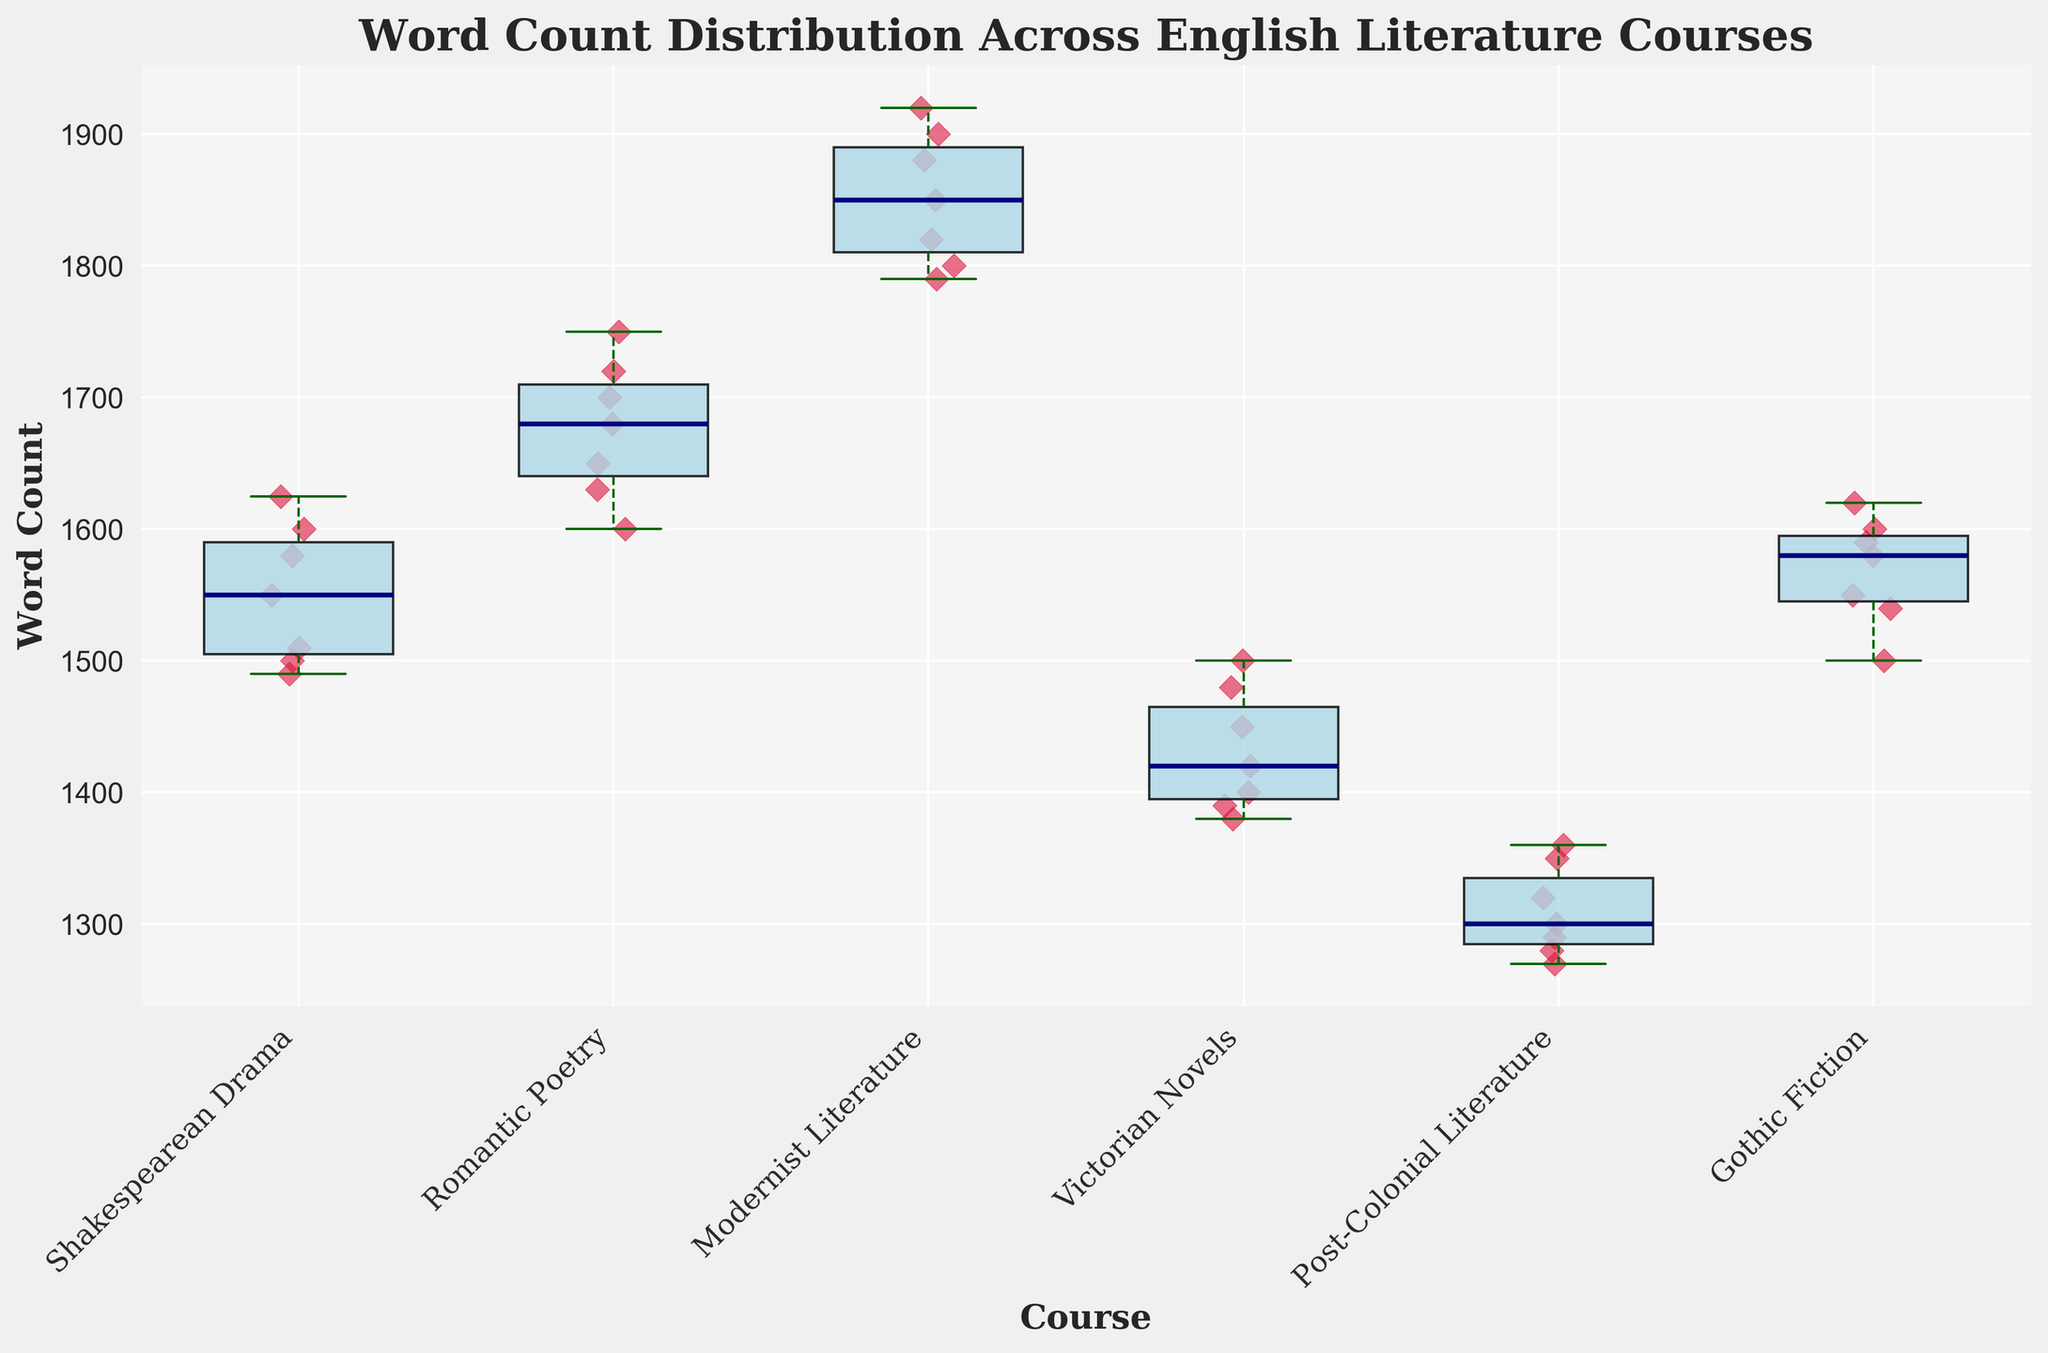What's the title of the figure? The title of the figure is the text located at the top of the plot, typically in a larger and bold font. It is explicitly defined and easy to identify.
Answer: Word Count Distribution Across English Literature Courses Which course has the highest median word count? The median word count of each course is represented by the bold line in the middle of each box. The highest median line appears to belong to the "Modernist Literature" course.
Answer: Modernist Literature Which course shows the greatest variation in word count? The variation in word count is indicated by the spread or length of the box and whiskers. The course with the widest box and longest whiskers represents the greatest variation. By examining these features, "Modernist Literature" appears to have the greatest variation.
Answer: Modernist Literature How many data points are there for the "Romantic Poetry" course? Each red scatter point represents a single data entry. By counting the red scatter points for "Romantic Poetry," we can determine the number of data points. There are seven scatter points, indicating seven data entries.
Answer: 7 Which courses have outliers, if any? Outliers in a box plot are represented as individual points beyond the whiskers. Courses with outlier points outside the whisker range need to be identified. In this plot, none of the courses have noticeable outliers.
Answer: None Which course has the lowest minimum word count? The minimum word count is indicated by the bottom whisker of each box plot. By identifying the lowest point of all the bottom whiskers, we find that "Post-Colonial Literature" has the lowest minimum word count.
Answer: Post-Colonial Literature What is the approximate range of word counts for "Victorian Novels"? The range of word counts is the difference between the maximum and minimum values represented by the top and bottom whiskers, respectively. For "Victorian Novels," the range can be estimated by looking at the top (1500) and bottom (1380) whiskers. The range is 1500 - 1380 = 120.
Answer: 120 Which two courses have the closest median word counts? The median word count is represented by the line in the middle of each box. By comparing these lines across courses, "Romantic Poetry" and "Gothic Fiction" have quite close median values.
Answer: Romantic Poetry and Gothic Fiction What does the color scheme represent in the plot? The different colors in the plot differentiate between various elements, such as the light blue boxes representing the spread of word counts, the navy lines indicating the median, and the crimson scatter points showing individual data entries.
Answer: Different elements Which course has the smallest interquartile range (IQR) and how is it determined? The IQR is indicated by the height of the box and represents the middle 50% of the data. Smaller boxes have a smaller IQR. "Post-Colonial Literature" has the smallest IQR as its box is the shortest.
Answer: Post-Colonial Literature 